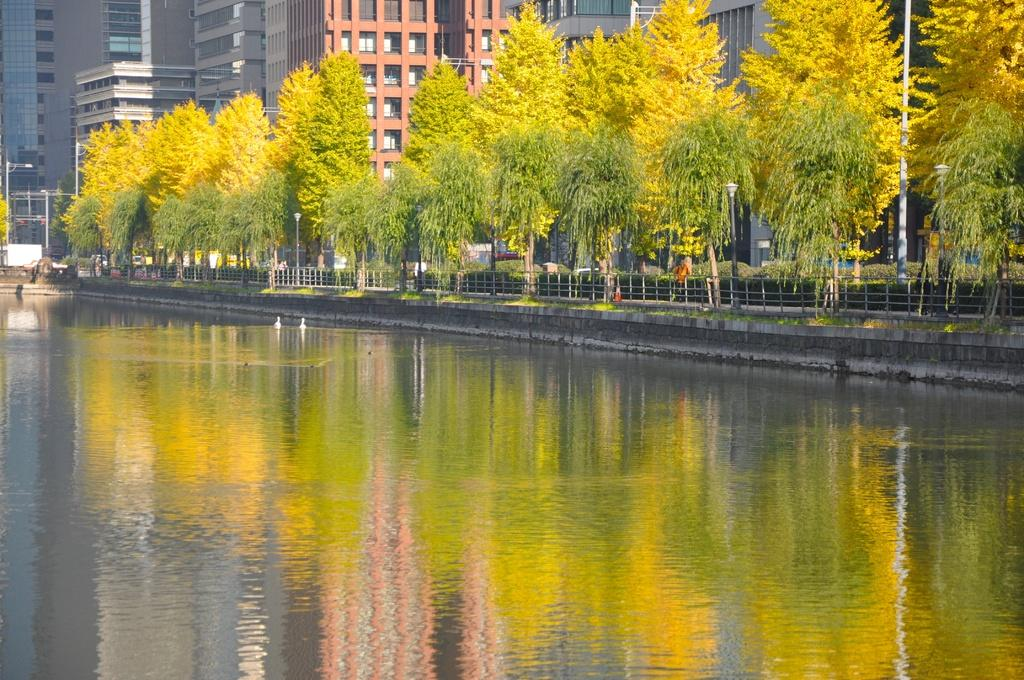What type of structures can be seen in the image? There are buildings in the image. What features do the buildings have? The buildings have windows. What type of vegetation is present in the image? There are trees in the image. What other objects can be seen in the image? There are poles, a fence, water, grass, and a path in the image. What type of furniture is visible in the image? There is no furniture present in the image. What idea is being conveyed through the image? The image does not convey a specific idea; it is a visual representation of various objects and structures. 